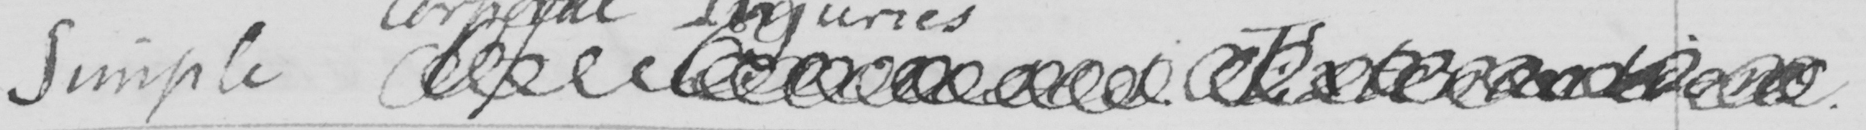Please transcribe the handwritten text in this image. Simple Of <gap/> Extenuations. 